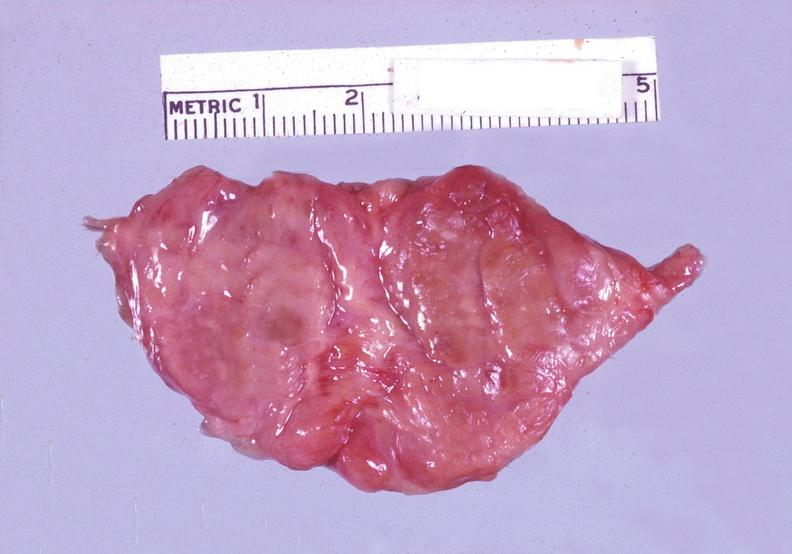s endocrine present?
Answer the question using a single word or phrase. Yes 